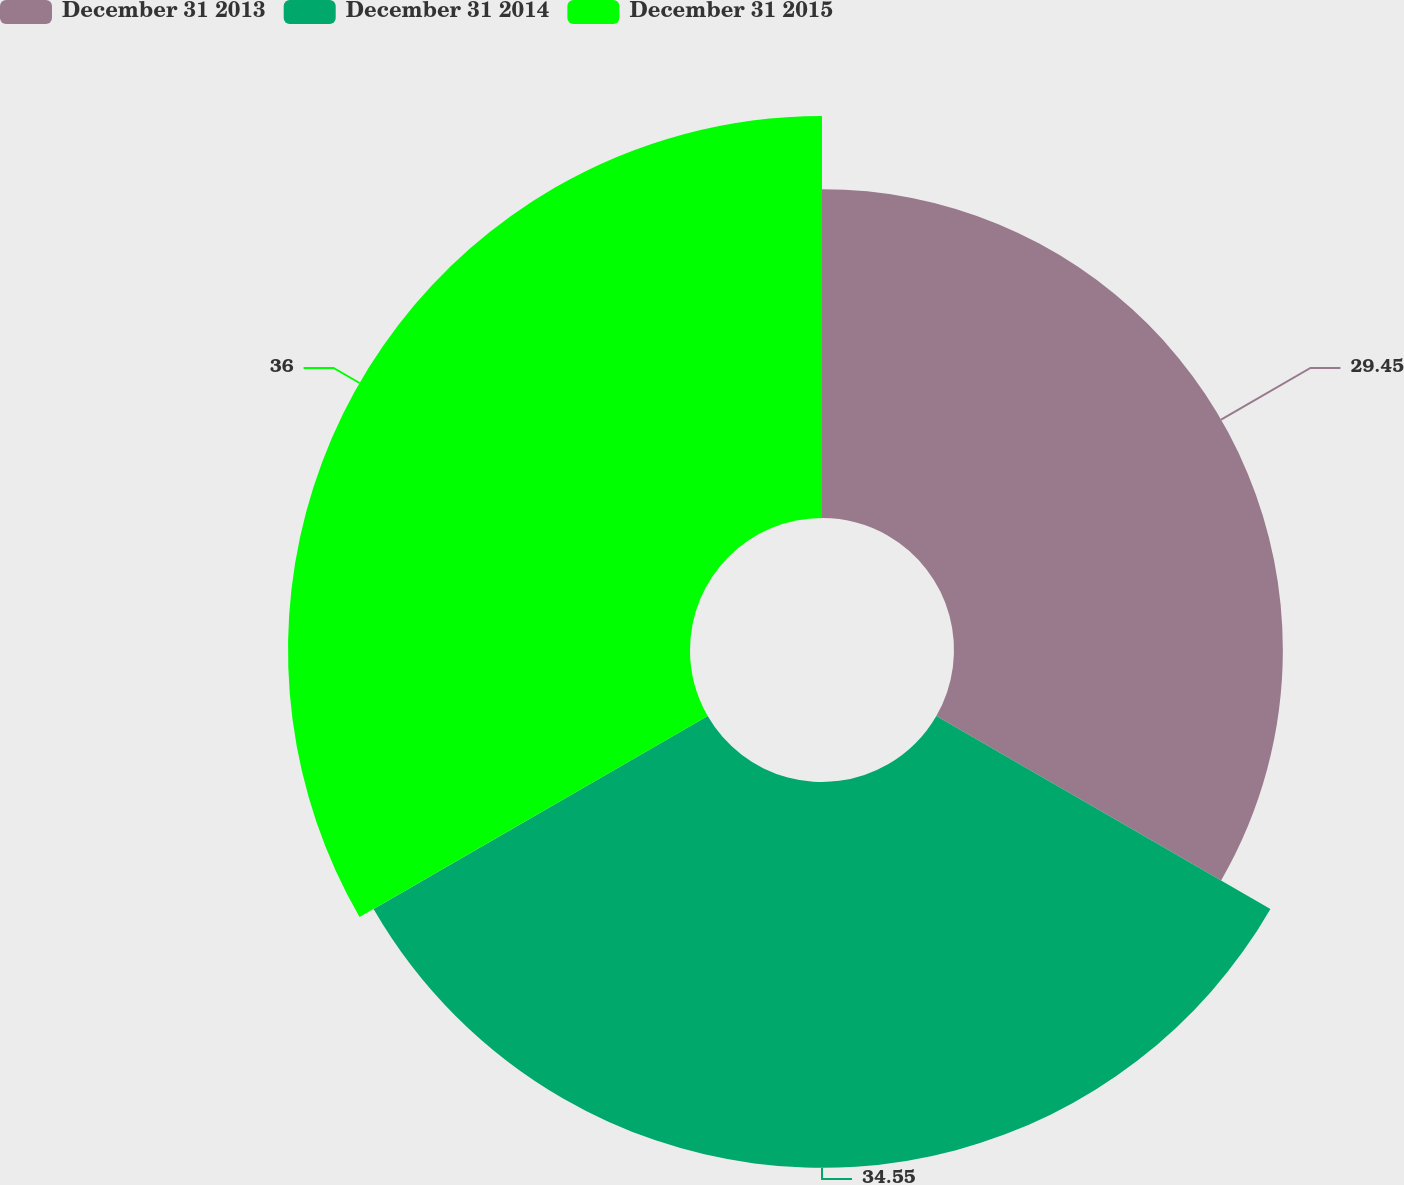<chart> <loc_0><loc_0><loc_500><loc_500><pie_chart><fcel>December 31 2013<fcel>December 31 2014<fcel>December 31 2015<nl><fcel>29.45%<fcel>34.55%<fcel>36.0%<nl></chart> 